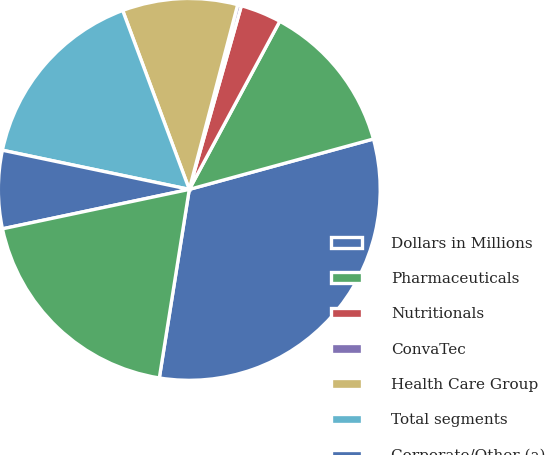Convert chart. <chart><loc_0><loc_0><loc_500><loc_500><pie_chart><fcel>Dollars in Millions<fcel>Pharmaceuticals<fcel>Nutritionals<fcel>ConvaTec<fcel>Health Care Group<fcel>Total segments<fcel>Corporate/Other (a)<fcel>Total<nl><fcel>31.76%<fcel>12.89%<fcel>3.46%<fcel>0.32%<fcel>9.75%<fcel>16.04%<fcel>6.6%<fcel>19.18%<nl></chart> 